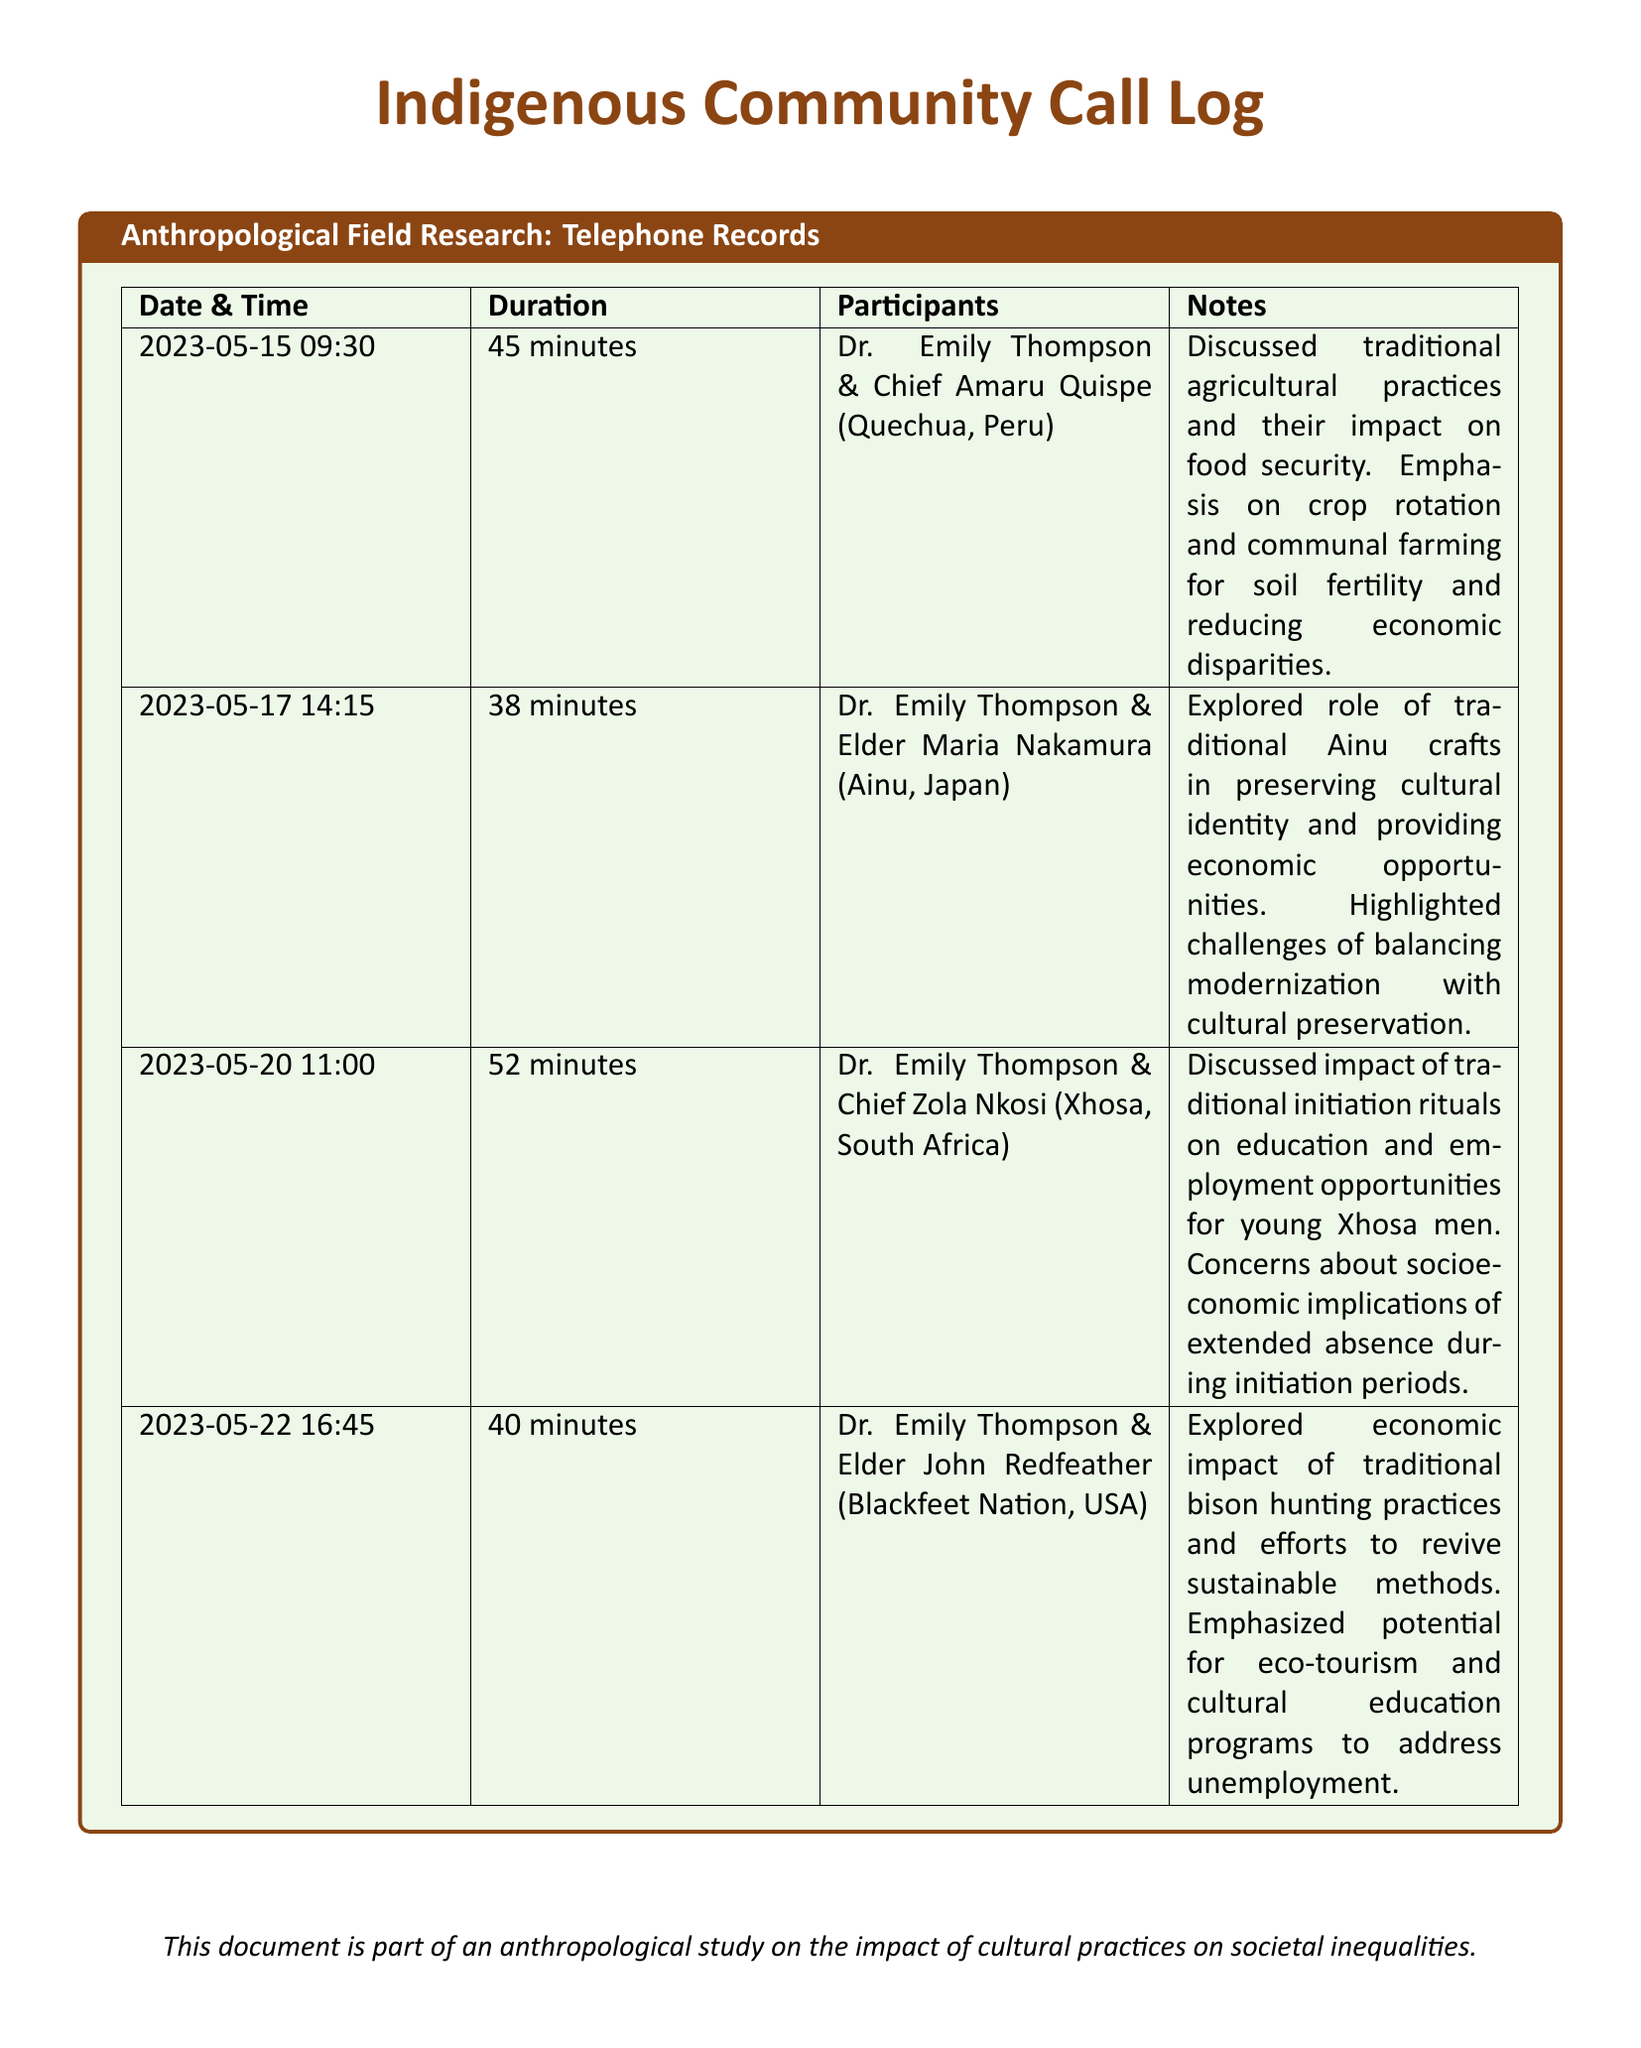What is the date of the conversation with Chief Amaru Quispe? The date is specified in the call log under the column "Date & Time" for the discussion with Chief Amaru Quispe.
Answer: 2023-05-15 Who participated in the call with Elder Maria Nakamura? The participants of the call with Elder Maria Nakamura are listed in the corresponding row of the table.
Answer: Dr. Emily Thompson & Elder Maria Nakamura What was the duration of the call with Chief Zola Nkosi? The call duration is indicated in the call log next to the date and participants' names.
Answer: 52 minutes What socioeconomic issue was discussed in the call with Elder John Redfeather? The socioeconomic issue is mentioned in the notes section for the call with Elder John Redfeather.
Answer: Unemployment How many calls were made in total? The total number of calls can be counted from the number of rows in this call log.
Answer: 4 What traditional practice was highlighted in the discussion with Chief Amaru Quispe? The traditional practice discussed with Chief Amaru Quispe can be found in the notes section of the call log.
Answer: Crop rotation What challenge is mentioned regarding traditional Ainu crafts? The challenge related to Ainu crafts is stated in the call log notes which discuss modernization versus preservation.
Answer: Balancing modernization with cultural preservation What potential economic opportunity was mentioned in the call with Elder John Redfeather? The potential opportunity is described in the notes related to the economic impact of traditional practices discussed in that call.
Answer: Eco-tourism 